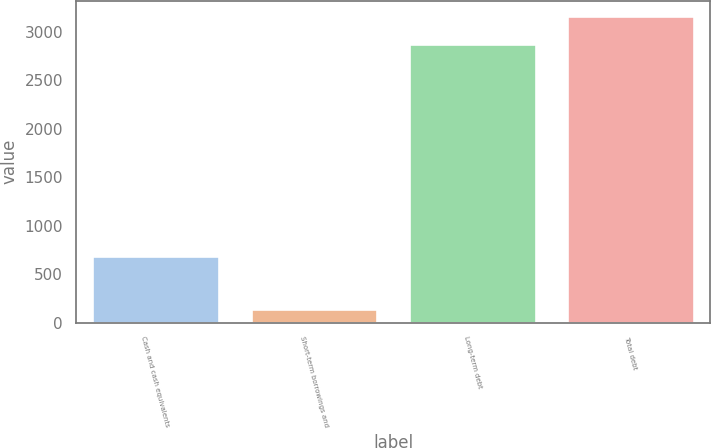Convert chart. <chart><loc_0><loc_0><loc_500><loc_500><bar_chart><fcel>Cash and cash equivalents<fcel>Short-term borrowings and<fcel>Long-term debt<fcel>Total debt<nl><fcel>682<fcel>144<fcel>2873<fcel>3160.3<nl></chart> 